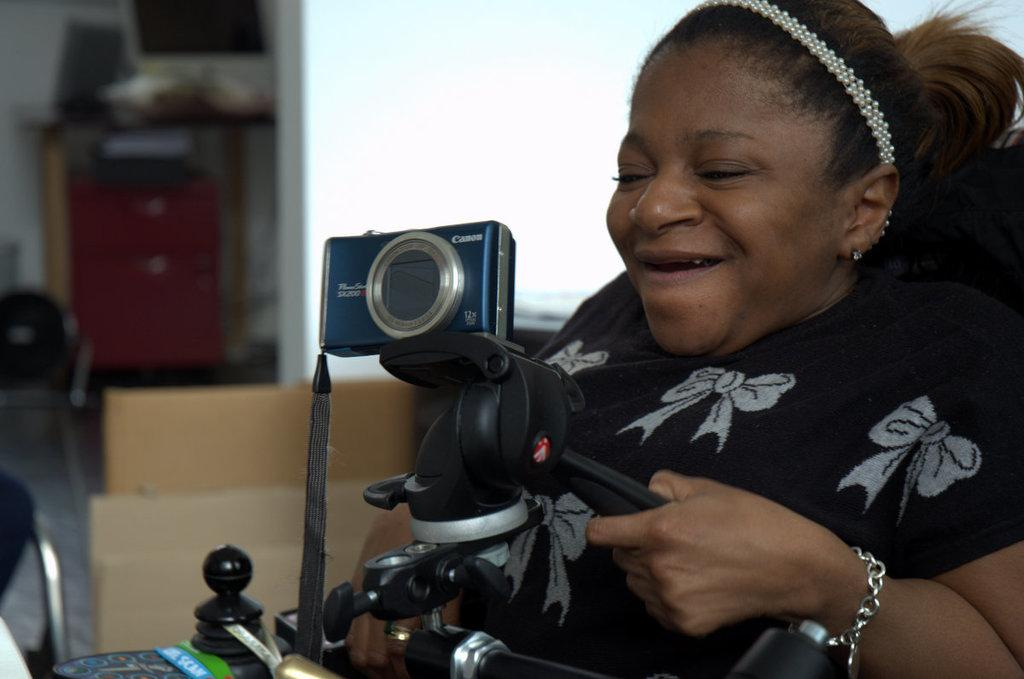What is located on the right side of the image? There is a woman on the right side of the image. What is the woman wearing? The woman is wearing a black dress. What is the woman holding in the image? The woman is holding a camera. What can be seen in the background of the image? There is a cupboard and a window in the background of the image. What type of corn can be seen growing in the image? There is no corn present in the image; it features a woman holding a camera. What angle is the woman's sense of humor displayed in the image? The image does not show the woman's sense of humor, so it cannot be determined from the image. 